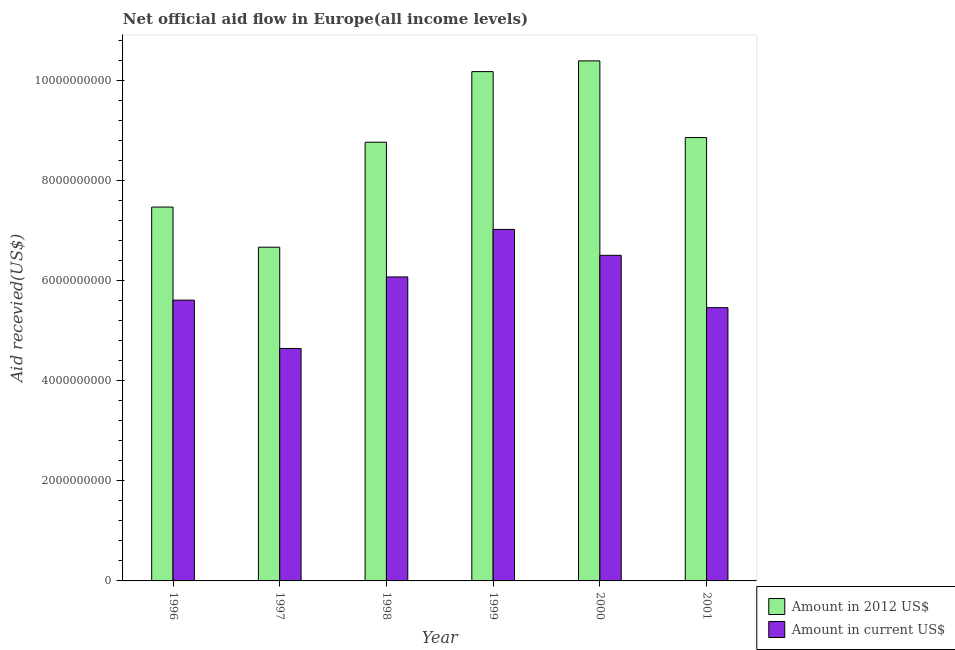How many groups of bars are there?
Offer a terse response. 6. What is the label of the 4th group of bars from the left?
Your answer should be compact. 1999. What is the amount of aid received(expressed in 2012 us$) in 2000?
Your answer should be compact. 1.04e+1. Across all years, what is the maximum amount of aid received(expressed in 2012 us$)?
Your answer should be very brief. 1.04e+1. Across all years, what is the minimum amount of aid received(expressed in 2012 us$)?
Offer a terse response. 6.67e+09. In which year was the amount of aid received(expressed in 2012 us$) minimum?
Ensure brevity in your answer.  1997. What is the total amount of aid received(expressed in 2012 us$) in the graph?
Offer a terse response. 5.24e+1. What is the difference between the amount of aid received(expressed in us$) in 1999 and that in 2001?
Provide a succinct answer. 1.57e+09. What is the difference between the amount of aid received(expressed in 2012 us$) in 2000 and the amount of aid received(expressed in us$) in 1999?
Offer a very short reply. 2.15e+08. What is the average amount of aid received(expressed in us$) per year?
Provide a short and direct response. 5.89e+09. In how many years, is the amount of aid received(expressed in 2012 us$) greater than 10000000000 US$?
Keep it short and to the point. 2. What is the ratio of the amount of aid received(expressed in 2012 us$) in 1998 to that in 2000?
Offer a very short reply. 0.84. Is the amount of aid received(expressed in 2012 us$) in 1996 less than that in 2001?
Make the answer very short. Yes. What is the difference between the highest and the second highest amount of aid received(expressed in 2012 us$)?
Offer a very short reply. 2.15e+08. What is the difference between the highest and the lowest amount of aid received(expressed in 2012 us$)?
Provide a short and direct response. 3.73e+09. In how many years, is the amount of aid received(expressed in us$) greater than the average amount of aid received(expressed in us$) taken over all years?
Your answer should be very brief. 3. Is the sum of the amount of aid received(expressed in 2012 us$) in 1998 and 2001 greater than the maximum amount of aid received(expressed in us$) across all years?
Your answer should be compact. Yes. What does the 2nd bar from the left in 1999 represents?
Provide a short and direct response. Amount in current US$. What does the 1st bar from the right in 1996 represents?
Offer a terse response. Amount in current US$. Where does the legend appear in the graph?
Provide a succinct answer. Bottom right. What is the title of the graph?
Your answer should be compact. Net official aid flow in Europe(all income levels). What is the label or title of the X-axis?
Make the answer very short. Year. What is the label or title of the Y-axis?
Your answer should be very brief. Aid recevied(US$). What is the Aid recevied(US$) in Amount in 2012 US$ in 1996?
Your response must be concise. 7.48e+09. What is the Aid recevied(US$) of Amount in current US$ in 1996?
Your answer should be very brief. 5.62e+09. What is the Aid recevied(US$) of Amount in 2012 US$ in 1997?
Provide a succinct answer. 6.67e+09. What is the Aid recevied(US$) in Amount in current US$ in 1997?
Ensure brevity in your answer.  4.65e+09. What is the Aid recevied(US$) in Amount in 2012 US$ in 1998?
Your response must be concise. 8.77e+09. What is the Aid recevied(US$) in Amount in current US$ in 1998?
Provide a succinct answer. 6.08e+09. What is the Aid recevied(US$) in Amount in 2012 US$ in 1999?
Offer a very short reply. 1.02e+1. What is the Aid recevied(US$) of Amount in current US$ in 1999?
Your answer should be compact. 7.03e+09. What is the Aid recevied(US$) of Amount in 2012 US$ in 2000?
Ensure brevity in your answer.  1.04e+1. What is the Aid recevied(US$) of Amount in current US$ in 2000?
Ensure brevity in your answer.  6.51e+09. What is the Aid recevied(US$) of Amount in 2012 US$ in 2001?
Offer a very short reply. 8.87e+09. What is the Aid recevied(US$) of Amount in current US$ in 2001?
Keep it short and to the point. 5.47e+09. Across all years, what is the maximum Aid recevied(US$) of Amount in 2012 US$?
Your response must be concise. 1.04e+1. Across all years, what is the maximum Aid recevied(US$) in Amount in current US$?
Keep it short and to the point. 7.03e+09. Across all years, what is the minimum Aid recevied(US$) of Amount in 2012 US$?
Ensure brevity in your answer.  6.67e+09. Across all years, what is the minimum Aid recevied(US$) of Amount in current US$?
Give a very brief answer. 4.65e+09. What is the total Aid recevied(US$) in Amount in 2012 US$ in the graph?
Ensure brevity in your answer.  5.24e+1. What is the total Aid recevied(US$) in Amount in current US$ in the graph?
Provide a succinct answer. 3.54e+1. What is the difference between the Aid recevied(US$) in Amount in 2012 US$ in 1996 and that in 1997?
Ensure brevity in your answer.  8.03e+08. What is the difference between the Aid recevied(US$) in Amount in current US$ in 1996 and that in 1997?
Your answer should be very brief. 9.66e+08. What is the difference between the Aid recevied(US$) in Amount in 2012 US$ in 1996 and that in 1998?
Make the answer very short. -1.30e+09. What is the difference between the Aid recevied(US$) of Amount in current US$ in 1996 and that in 1998?
Offer a very short reply. -4.64e+08. What is the difference between the Aid recevied(US$) of Amount in 2012 US$ in 1996 and that in 1999?
Your answer should be compact. -2.71e+09. What is the difference between the Aid recevied(US$) in Amount in current US$ in 1996 and that in 1999?
Provide a succinct answer. -1.41e+09. What is the difference between the Aid recevied(US$) in Amount in 2012 US$ in 1996 and that in 2000?
Ensure brevity in your answer.  -2.92e+09. What is the difference between the Aid recevied(US$) in Amount in current US$ in 1996 and that in 2000?
Give a very brief answer. -8.96e+08. What is the difference between the Aid recevied(US$) in Amount in 2012 US$ in 1996 and that in 2001?
Provide a succinct answer. -1.39e+09. What is the difference between the Aid recevied(US$) of Amount in current US$ in 1996 and that in 2001?
Your response must be concise. 1.50e+08. What is the difference between the Aid recevied(US$) in Amount in 2012 US$ in 1997 and that in 1998?
Provide a short and direct response. -2.10e+09. What is the difference between the Aid recevied(US$) of Amount in current US$ in 1997 and that in 1998?
Provide a succinct answer. -1.43e+09. What is the difference between the Aid recevied(US$) in Amount in 2012 US$ in 1997 and that in 1999?
Give a very brief answer. -3.51e+09. What is the difference between the Aid recevied(US$) in Amount in current US$ in 1997 and that in 1999?
Offer a terse response. -2.38e+09. What is the difference between the Aid recevied(US$) of Amount in 2012 US$ in 1997 and that in 2000?
Ensure brevity in your answer.  -3.73e+09. What is the difference between the Aid recevied(US$) in Amount in current US$ in 1997 and that in 2000?
Provide a short and direct response. -1.86e+09. What is the difference between the Aid recevied(US$) of Amount in 2012 US$ in 1997 and that in 2001?
Make the answer very short. -2.19e+09. What is the difference between the Aid recevied(US$) in Amount in current US$ in 1997 and that in 2001?
Your answer should be compact. -8.16e+08. What is the difference between the Aid recevied(US$) of Amount in 2012 US$ in 1998 and that in 1999?
Offer a terse response. -1.41e+09. What is the difference between the Aid recevied(US$) in Amount in current US$ in 1998 and that in 1999?
Ensure brevity in your answer.  -9.51e+08. What is the difference between the Aid recevied(US$) in Amount in 2012 US$ in 1998 and that in 2000?
Make the answer very short. -1.63e+09. What is the difference between the Aid recevied(US$) in Amount in current US$ in 1998 and that in 2000?
Your answer should be very brief. -4.32e+08. What is the difference between the Aid recevied(US$) in Amount in 2012 US$ in 1998 and that in 2001?
Offer a terse response. -9.31e+07. What is the difference between the Aid recevied(US$) of Amount in current US$ in 1998 and that in 2001?
Give a very brief answer. 6.14e+08. What is the difference between the Aid recevied(US$) of Amount in 2012 US$ in 1999 and that in 2000?
Ensure brevity in your answer.  -2.15e+08. What is the difference between the Aid recevied(US$) in Amount in current US$ in 1999 and that in 2000?
Make the answer very short. 5.19e+08. What is the difference between the Aid recevied(US$) in Amount in 2012 US$ in 1999 and that in 2001?
Give a very brief answer. 1.32e+09. What is the difference between the Aid recevied(US$) of Amount in current US$ in 1999 and that in 2001?
Keep it short and to the point. 1.57e+09. What is the difference between the Aid recevied(US$) in Amount in 2012 US$ in 2000 and that in 2001?
Provide a short and direct response. 1.53e+09. What is the difference between the Aid recevied(US$) in Amount in current US$ in 2000 and that in 2001?
Give a very brief answer. 1.05e+09. What is the difference between the Aid recevied(US$) in Amount in 2012 US$ in 1996 and the Aid recevied(US$) in Amount in current US$ in 1997?
Provide a short and direct response. 2.83e+09. What is the difference between the Aid recevied(US$) of Amount in 2012 US$ in 1996 and the Aid recevied(US$) of Amount in current US$ in 1998?
Offer a terse response. 1.40e+09. What is the difference between the Aid recevied(US$) of Amount in 2012 US$ in 1996 and the Aid recevied(US$) of Amount in current US$ in 1999?
Offer a terse response. 4.47e+08. What is the difference between the Aid recevied(US$) in Amount in 2012 US$ in 1996 and the Aid recevied(US$) in Amount in current US$ in 2000?
Your response must be concise. 9.66e+08. What is the difference between the Aid recevied(US$) in Amount in 2012 US$ in 1996 and the Aid recevied(US$) in Amount in current US$ in 2001?
Give a very brief answer. 2.01e+09. What is the difference between the Aid recevied(US$) of Amount in 2012 US$ in 1997 and the Aid recevied(US$) of Amount in current US$ in 1998?
Provide a succinct answer. 5.95e+08. What is the difference between the Aid recevied(US$) of Amount in 2012 US$ in 1997 and the Aid recevied(US$) of Amount in current US$ in 1999?
Provide a succinct answer. -3.56e+08. What is the difference between the Aid recevied(US$) in Amount in 2012 US$ in 1997 and the Aid recevied(US$) in Amount in current US$ in 2000?
Keep it short and to the point. 1.63e+08. What is the difference between the Aid recevied(US$) in Amount in 2012 US$ in 1997 and the Aid recevied(US$) in Amount in current US$ in 2001?
Keep it short and to the point. 1.21e+09. What is the difference between the Aid recevied(US$) of Amount in 2012 US$ in 1998 and the Aid recevied(US$) of Amount in current US$ in 1999?
Make the answer very short. 1.74e+09. What is the difference between the Aid recevied(US$) of Amount in 2012 US$ in 1998 and the Aid recevied(US$) of Amount in current US$ in 2000?
Your answer should be very brief. 2.26e+09. What is the difference between the Aid recevied(US$) of Amount in 2012 US$ in 1998 and the Aid recevied(US$) of Amount in current US$ in 2001?
Offer a very short reply. 3.31e+09. What is the difference between the Aid recevied(US$) in Amount in 2012 US$ in 1999 and the Aid recevied(US$) in Amount in current US$ in 2000?
Offer a very short reply. 3.67e+09. What is the difference between the Aid recevied(US$) in Amount in 2012 US$ in 1999 and the Aid recevied(US$) in Amount in current US$ in 2001?
Your answer should be compact. 4.72e+09. What is the difference between the Aid recevied(US$) in Amount in 2012 US$ in 2000 and the Aid recevied(US$) in Amount in current US$ in 2001?
Offer a very short reply. 4.94e+09. What is the average Aid recevied(US$) of Amount in 2012 US$ per year?
Give a very brief answer. 8.73e+09. What is the average Aid recevied(US$) in Amount in current US$ per year?
Offer a very short reply. 5.89e+09. In the year 1996, what is the difference between the Aid recevied(US$) of Amount in 2012 US$ and Aid recevied(US$) of Amount in current US$?
Your answer should be compact. 1.86e+09. In the year 1997, what is the difference between the Aid recevied(US$) in Amount in 2012 US$ and Aid recevied(US$) in Amount in current US$?
Provide a short and direct response. 2.03e+09. In the year 1998, what is the difference between the Aid recevied(US$) of Amount in 2012 US$ and Aid recevied(US$) of Amount in current US$?
Provide a short and direct response. 2.69e+09. In the year 1999, what is the difference between the Aid recevied(US$) of Amount in 2012 US$ and Aid recevied(US$) of Amount in current US$?
Provide a short and direct response. 3.16e+09. In the year 2000, what is the difference between the Aid recevied(US$) of Amount in 2012 US$ and Aid recevied(US$) of Amount in current US$?
Your answer should be compact. 3.89e+09. In the year 2001, what is the difference between the Aid recevied(US$) of Amount in 2012 US$ and Aid recevied(US$) of Amount in current US$?
Ensure brevity in your answer.  3.40e+09. What is the ratio of the Aid recevied(US$) of Amount in 2012 US$ in 1996 to that in 1997?
Ensure brevity in your answer.  1.12. What is the ratio of the Aid recevied(US$) in Amount in current US$ in 1996 to that in 1997?
Offer a terse response. 1.21. What is the ratio of the Aid recevied(US$) of Amount in 2012 US$ in 1996 to that in 1998?
Make the answer very short. 0.85. What is the ratio of the Aid recevied(US$) of Amount in current US$ in 1996 to that in 1998?
Make the answer very short. 0.92. What is the ratio of the Aid recevied(US$) in Amount in 2012 US$ in 1996 to that in 1999?
Offer a very short reply. 0.73. What is the ratio of the Aid recevied(US$) of Amount in current US$ in 1996 to that in 1999?
Keep it short and to the point. 0.8. What is the ratio of the Aid recevied(US$) of Amount in 2012 US$ in 1996 to that in 2000?
Your response must be concise. 0.72. What is the ratio of the Aid recevied(US$) in Amount in current US$ in 1996 to that in 2000?
Your answer should be compact. 0.86. What is the ratio of the Aid recevied(US$) in Amount in 2012 US$ in 1996 to that in 2001?
Provide a succinct answer. 0.84. What is the ratio of the Aid recevied(US$) of Amount in current US$ in 1996 to that in 2001?
Your response must be concise. 1.03. What is the ratio of the Aid recevied(US$) of Amount in 2012 US$ in 1997 to that in 1998?
Make the answer very short. 0.76. What is the ratio of the Aid recevied(US$) of Amount in current US$ in 1997 to that in 1998?
Your response must be concise. 0.76. What is the ratio of the Aid recevied(US$) of Amount in 2012 US$ in 1997 to that in 1999?
Offer a terse response. 0.66. What is the ratio of the Aid recevied(US$) of Amount in current US$ in 1997 to that in 1999?
Offer a very short reply. 0.66. What is the ratio of the Aid recevied(US$) in Amount in 2012 US$ in 1997 to that in 2000?
Your answer should be compact. 0.64. What is the ratio of the Aid recevied(US$) in Amount in current US$ in 1997 to that in 2000?
Keep it short and to the point. 0.71. What is the ratio of the Aid recevied(US$) of Amount in 2012 US$ in 1997 to that in 2001?
Keep it short and to the point. 0.75. What is the ratio of the Aid recevied(US$) in Amount in current US$ in 1997 to that in 2001?
Provide a short and direct response. 0.85. What is the ratio of the Aid recevied(US$) of Amount in 2012 US$ in 1998 to that in 1999?
Your answer should be compact. 0.86. What is the ratio of the Aid recevied(US$) of Amount in current US$ in 1998 to that in 1999?
Provide a short and direct response. 0.86. What is the ratio of the Aid recevied(US$) in Amount in 2012 US$ in 1998 to that in 2000?
Provide a succinct answer. 0.84. What is the ratio of the Aid recevied(US$) of Amount in current US$ in 1998 to that in 2000?
Make the answer very short. 0.93. What is the ratio of the Aid recevied(US$) of Amount in 2012 US$ in 1998 to that in 2001?
Your response must be concise. 0.99. What is the ratio of the Aid recevied(US$) in Amount in current US$ in 1998 to that in 2001?
Your answer should be compact. 1.11. What is the ratio of the Aid recevied(US$) of Amount in 2012 US$ in 1999 to that in 2000?
Keep it short and to the point. 0.98. What is the ratio of the Aid recevied(US$) in Amount in current US$ in 1999 to that in 2000?
Provide a short and direct response. 1.08. What is the ratio of the Aid recevied(US$) of Amount in 2012 US$ in 1999 to that in 2001?
Ensure brevity in your answer.  1.15. What is the ratio of the Aid recevied(US$) in Amount in current US$ in 1999 to that in 2001?
Make the answer very short. 1.29. What is the ratio of the Aid recevied(US$) of Amount in 2012 US$ in 2000 to that in 2001?
Make the answer very short. 1.17. What is the ratio of the Aid recevied(US$) in Amount in current US$ in 2000 to that in 2001?
Your answer should be compact. 1.19. What is the difference between the highest and the second highest Aid recevied(US$) of Amount in 2012 US$?
Your answer should be very brief. 2.15e+08. What is the difference between the highest and the second highest Aid recevied(US$) in Amount in current US$?
Provide a succinct answer. 5.19e+08. What is the difference between the highest and the lowest Aid recevied(US$) of Amount in 2012 US$?
Your answer should be compact. 3.73e+09. What is the difference between the highest and the lowest Aid recevied(US$) in Amount in current US$?
Your response must be concise. 2.38e+09. 